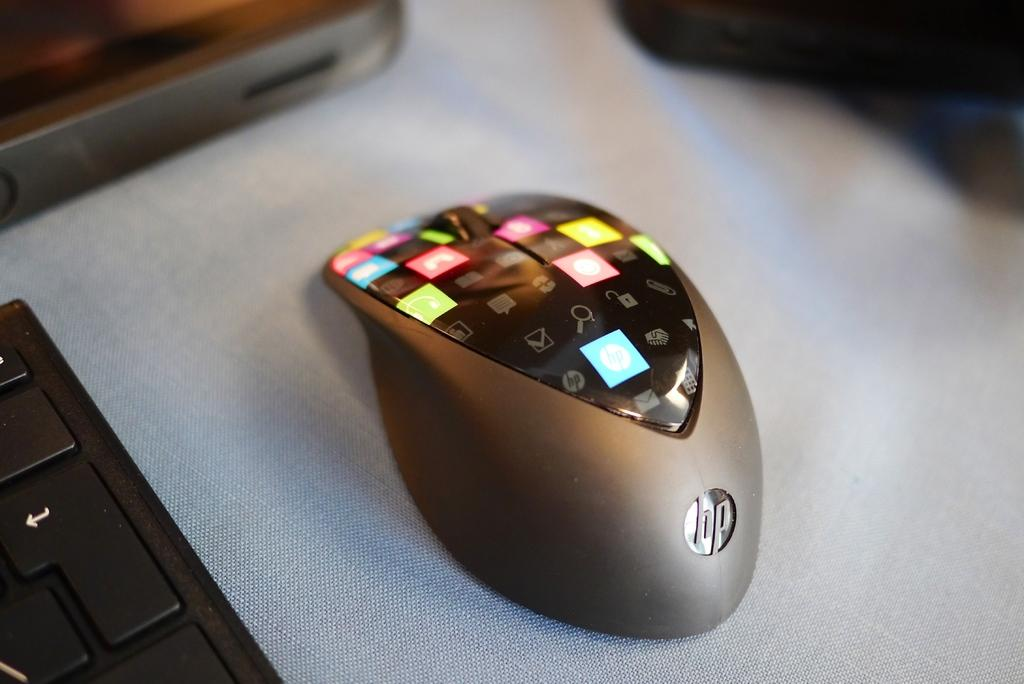Provide a one-sentence caption for the provided image. hp mouse with a digital display on top that is broken down into small squares, each one with a different picture of function. 